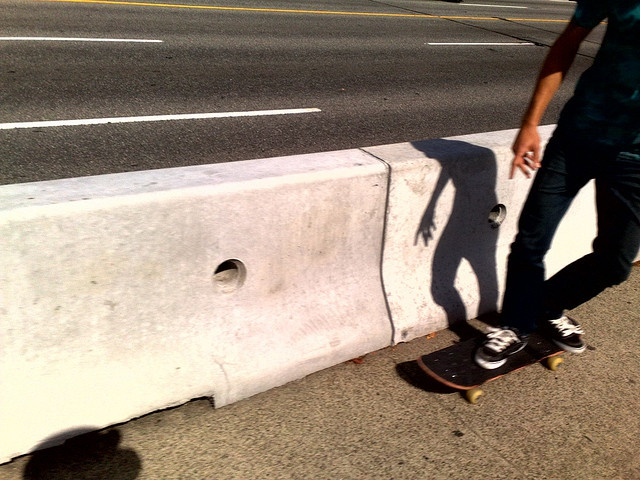Describe the objects in this image and their specific colors. I can see people in tan, black, ivory, gray, and maroon tones and skateboard in tan, black, gray, and maroon tones in this image. 